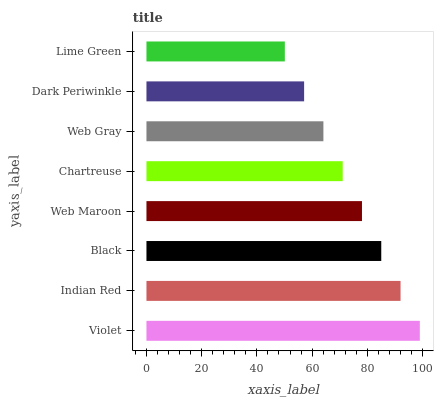Is Lime Green the minimum?
Answer yes or no. Yes. Is Violet the maximum?
Answer yes or no. Yes. Is Indian Red the minimum?
Answer yes or no. No. Is Indian Red the maximum?
Answer yes or no. No. Is Violet greater than Indian Red?
Answer yes or no. Yes. Is Indian Red less than Violet?
Answer yes or no. Yes. Is Indian Red greater than Violet?
Answer yes or no. No. Is Violet less than Indian Red?
Answer yes or no. No. Is Web Maroon the high median?
Answer yes or no. Yes. Is Chartreuse the low median?
Answer yes or no. Yes. Is Black the high median?
Answer yes or no. No. Is Web Gray the low median?
Answer yes or no. No. 